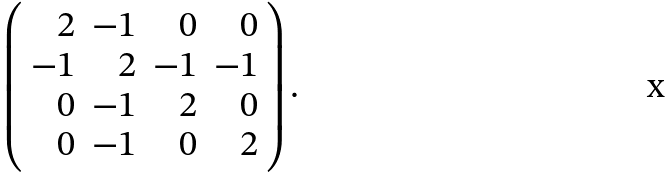Convert formula to latex. <formula><loc_0><loc_0><loc_500><loc_500>\left ( \begin{array} { r r r r } 2 & - 1 & 0 & 0 \\ - 1 & 2 & - 1 & - 1 \\ 0 & - 1 & 2 & 0 \\ 0 & - 1 & 0 & 2 \end{array} \right ) .</formula> 